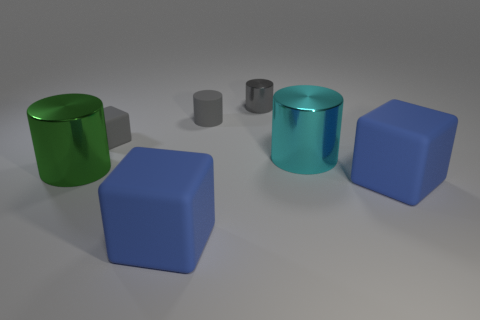Subtract 2 cylinders. How many cylinders are left? 2 Add 3 cyan metallic objects. How many objects exist? 10 Subtract all large blue blocks. How many blocks are left? 1 Subtract all cubes. How many objects are left? 4 Subtract all red cylinders. How many gray cubes are left? 1 Subtract all tiny rubber cubes. Subtract all tiny things. How many objects are left? 3 Add 3 green metal cylinders. How many green metal cylinders are left? 4 Add 6 blue blocks. How many blue blocks exist? 8 Subtract all blue cubes. How many cubes are left? 1 Subtract 0 brown cylinders. How many objects are left? 7 